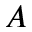Convert formula to latex. <formula><loc_0><loc_0><loc_500><loc_500>A</formula> 